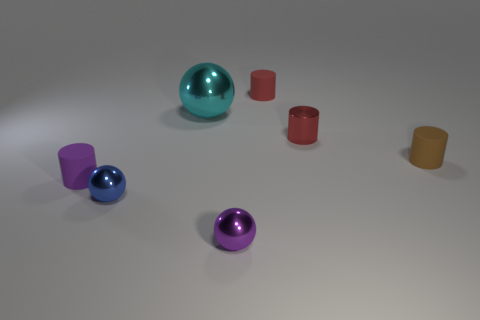Add 3 tiny red cylinders. How many objects exist? 10 Subtract all cylinders. How many objects are left? 3 Add 7 tiny brown things. How many tiny brown things exist? 8 Subtract 0 brown balls. How many objects are left? 7 Subtract all big brown metallic blocks. Subtract all purple rubber things. How many objects are left? 6 Add 7 metal spheres. How many metal spheres are left? 10 